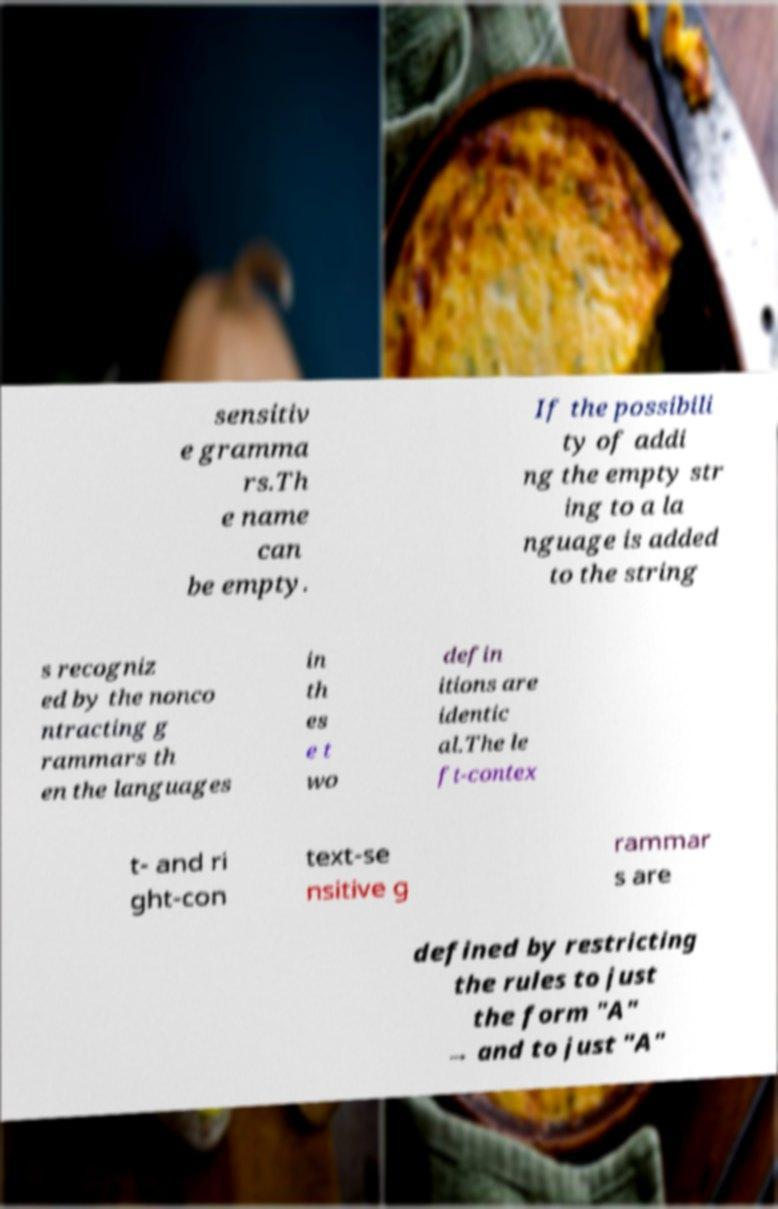Could you assist in decoding the text presented in this image and type it out clearly? sensitiv e gramma rs.Th e name can be empty. If the possibili ty of addi ng the empty str ing to a la nguage is added to the string s recogniz ed by the nonco ntracting g rammars th en the languages in th es e t wo defin itions are identic al.The le ft-contex t- and ri ght-con text-se nsitive g rammar s are defined by restricting the rules to just the form "A" → and to just "A" 